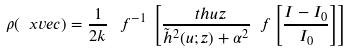<formula> <loc_0><loc_0><loc_500><loc_500>\rho ( \ x v e c ) = \frac { 1 } { 2 k } \, \ f ^ { - 1 } \, \left [ \frac { \ t h u z } { \tilde { h } ^ { 2 } ( u ; z ) + \alpha ^ { 2 } } \ f \left [ \frac { I - I _ { 0 } } { I _ { 0 } } \right ] \right ]</formula> 